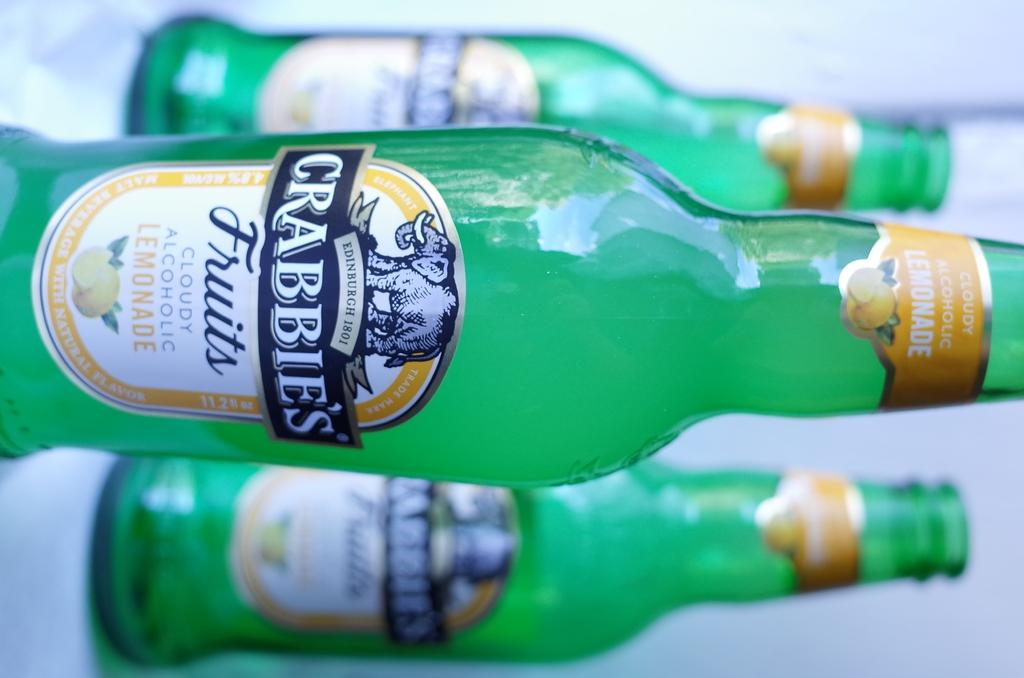<image>
Present a compact description of the photo's key features. A sideways view of three bottles with the label Crabbie's fruits 